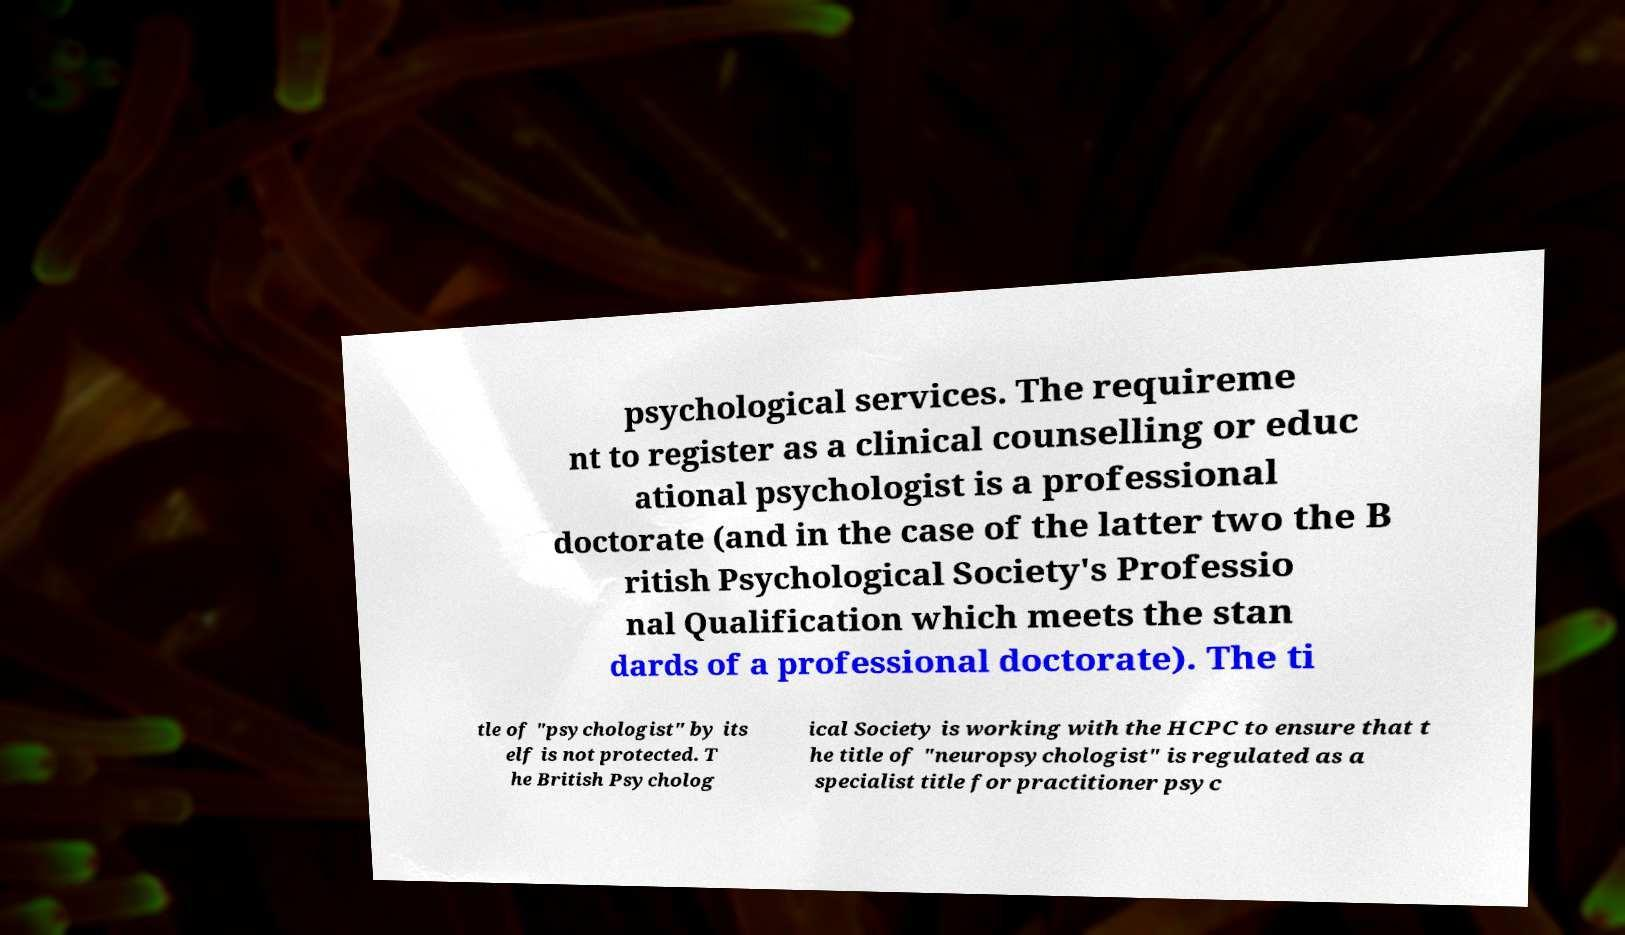For documentation purposes, I need the text within this image transcribed. Could you provide that? psychological services. The requireme nt to register as a clinical counselling or educ ational psychologist is a professional doctorate (and in the case of the latter two the B ritish Psychological Society's Professio nal Qualification which meets the stan dards of a professional doctorate). The ti tle of "psychologist" by its elf is not protected. T he British Psycholog ical Society is working with the HCPC to ensure that t he title of "neuropsychologist" is regulated as a specialist title for practitioner psyc 